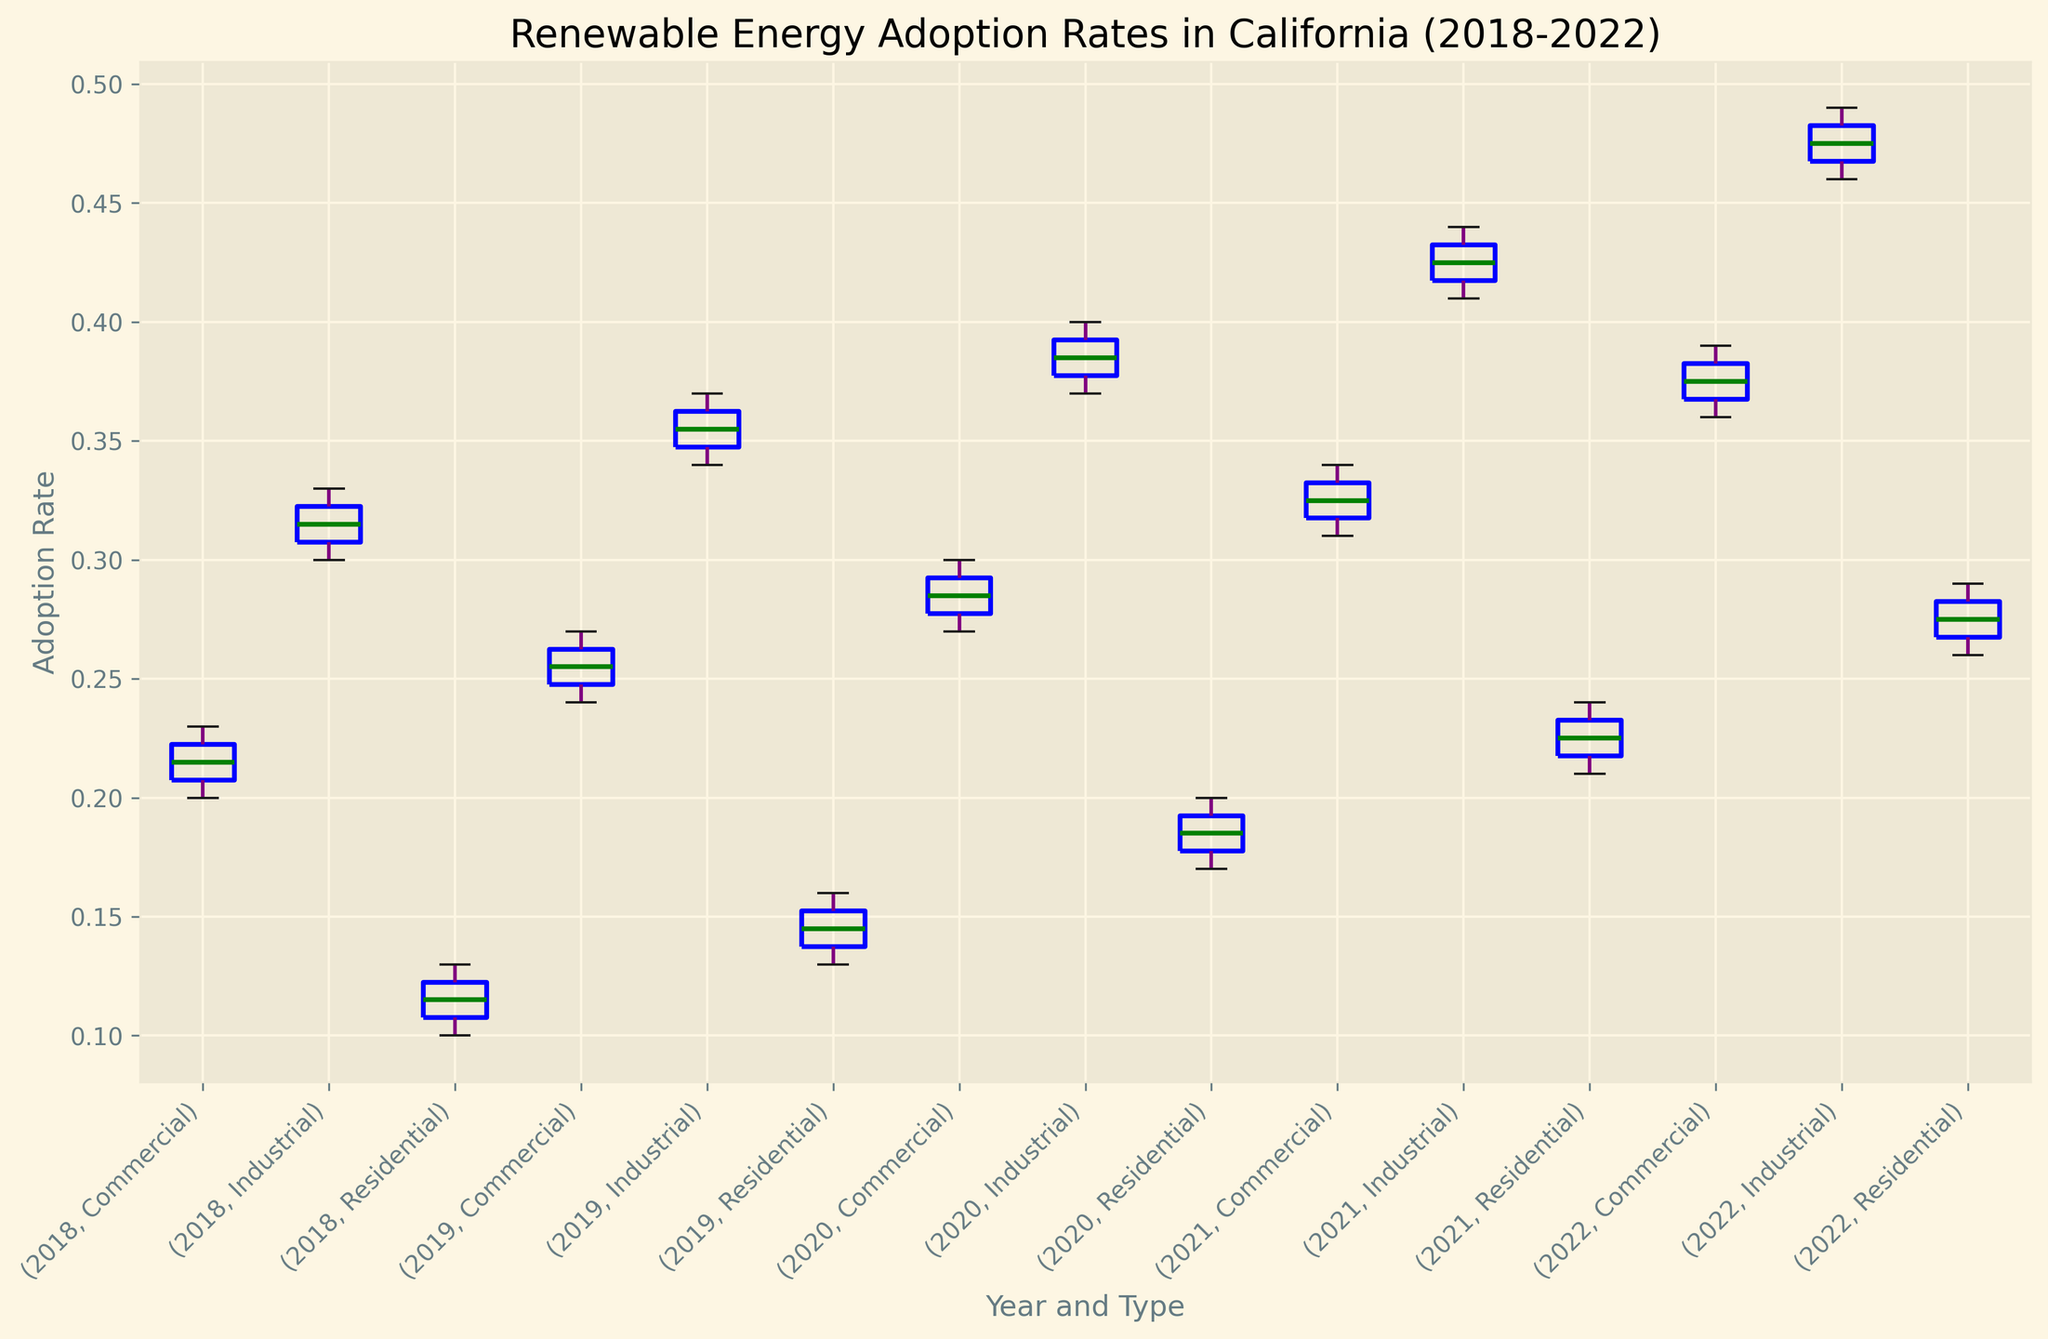What is the median adoption rate for the residential sector in 2020? Locate the box plot for the 2020 residential sector and identify the horizontal line inside the box, which represents the median value.
Answer: 0.185 How does the range of adoption rates for the industrial sector in 2021 compare to that in 2018? Compare the lengths of the boxes and whiskers of the industrial sector for both years. The range can be calculated from the minimum and maximum values.
Answer: The range is larger in 2021 Which year showed the highest median adoption rate for the commercial sector? Identify the commercial box plot for each year and locate the median lines. Compare the heights of these lines across the years.
Answer: 2022 Did the residential sector see a trend of increasing or decreasing adoption rates from 2018 to 2022? Observe the median lines for the residential sector box plots from 2018 to 2022. If the lines generally move upwards, there's an increasing trend; if downwards, a decreasing trend.
Answer: Increasing Which sector had the highest increase in the median adoption rate between 2020 and 2021? Compare the medians of the corresponding box plots for 2020 and 2021 for each sector. Calculate the difference for each sector and identify the highest increase.
Answer: Industrial Compare the variability in adoption rates in 2022 for the residential and commercial sectors. Look at the length of the boxes and whiskers for the residential and commercial sectors in 2022; longer boxes and whiskers indicate higher variability.
Answer: Commercial has higher variability Is the median adoption rate for the industrial sector always higher than that for the commercial sector in every year? Compare the median lines of the industrial and commercial box plots within each year from 2018 to 2022.
Answer: Yes What is the interquartile range (IQR) for the commercial sector in 2019? Identify the ends of the box (the first quartile Q1 and the third quartile Q3) for the commercial sector in 2019. Subtract Q1 from Q3.
Answer: 0.27 - 0.245 = 0.025 Between which years did the residential sector experience the largest median adoption rate increase? Compute the difference in median values between successive years for the residential sector and identify the largest increase.
Answer: 2021 to 2022 Does the figure show any outliers for any sector in any year? Visually inspect the box plots for any points that fall outside the whiskers, which represent outliers.
Answer: No 